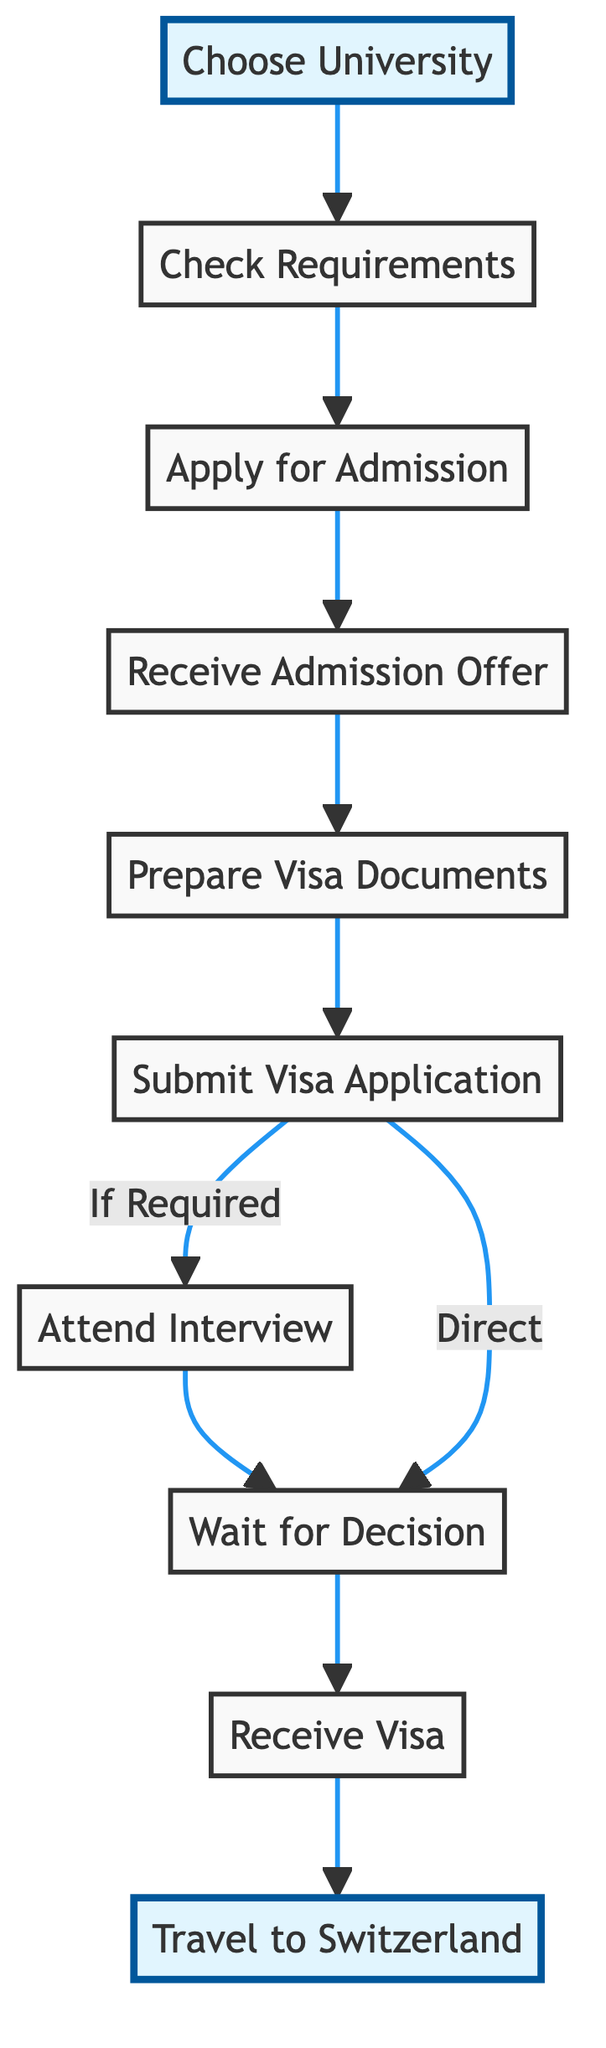What is the first step in the visa application process? The diagram starts with the node labeled "Choose University," indicating this is the initial step in the process of obtaining a student visa.
Answer: Choose University How many steps are involved in the visa application process? By counting the nodes in the diagram, we have a total of 10 steps, from "Choose University" to "Travel to Switzerland."
Answer: 10 What is the last step in the process? The last step in the flowchart is "Travel to Switzerland," which indicates the final action taken after receiving the visa.
Answer: Travel to Switzerland Do you need to attend an interview after submitting the visa application? The diagram shows a conditional "If Required" fork after "Submit Visa Application," indicating that attending an interview may be necessary, depending on individual circumstances.
Answer: Yes What happens if you receive an admission offer? After receiving an admission offer, the next step is to "Prepare Visa Documents," as indicated by the flow from "Receive Admission Offer" to "Prepare Visa Documents."
Answer: Prepare Visa Documents How does one proceed if an interview is not required? The flowchart indicates that if no interview is required, one directly proceeds from "Submit Visa Application" to "Wait for Decision."
Answer: Wait for Decision Which step occurs directly after preparing visa documents? In the diagram, after "Prepare Visa Documents," the next step is "Submit Visa Application," establishing a sequential connection between these two nodes.
Answer: Submit Visa Application What is the decision stage in the visa application process? The decision stage is labeled "Wait for Decision," where the applicant must wait for the outcome of their visa application after submission or interview.
Answer: Wait for Decision Which steps are highlighted in the diagram? The highlighted steps are "Choose University" and "Travel to Switzerland," indicating their significance in the overall process.
Answer: Choose University, Travel to Switzerland 